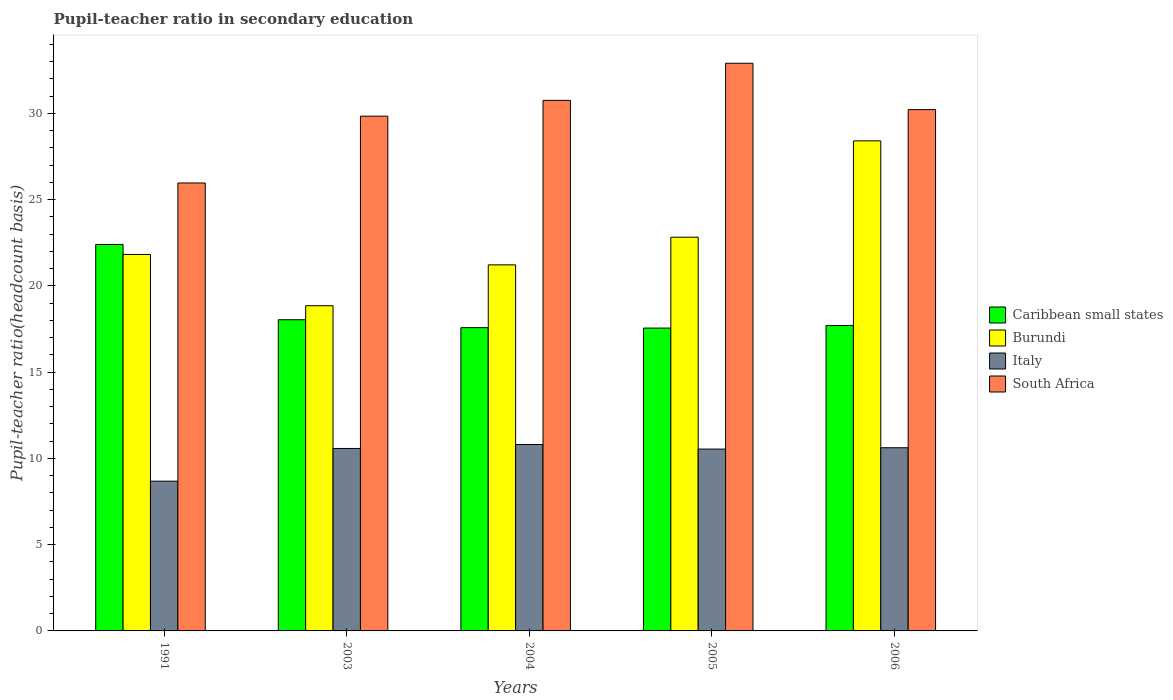How many different coloured bars are there?
Provide a short and direct response. 4. Are the number of bars per tick equal to the number of legend labels?
Ensure brevity in your answer.  Yes. Are the number of bars on each tick of the X-axis equal?
Provide a short and direct response. Yes. How many bars are there on the 5th tick from the left?
Your answer should be compact. 4. What is the label of the 1st group of bars from the left?
Your answer should be very brief. 1991. What is the pupil-teacher ratio in secondary education in Burundi in 2004?
Offer a very short reply. 21.22. Across all years, what is the maximum pupil-teacher ratio in secondary education in South Africa?
Provide a short and direct response. 32.9. Across all years, what is the minimum pupil-teacher ratio in secondary education in Caribbean small states?
Make the answer very short. 17.55. What is the total pupil-teacher ratio in secondary education in Caribbean small states in the graph?
Make the answer very short. 93.27. What is the difference between the pupil-teacher ratio in secondary education in Caribbean small states in 1991 and that in 2004?
Offer a very short reply. 4.82. What is the difference between the pupil-teacher ratio in secondary education in South Africa in 2005 and the pupil-teacher ratio in secondary education in Burundi in 2003?
Provide a short and direct response. 14.05. What is the average pupil-teacher ratio in secondary education in South Africa per year?
Make the answer very short. 29.93. In the year 1991, what is the difference between the pupil-teacher ratio in secondary education in Caribbean small states and pupil-teacher ratio in secondary education in South Africa?
Give a very brief answer. -3.56. In how many years, is the pupil-teacher ratio in secondary education in Italy greater than 13?
Provide a short and direct response. 0. What is the ratio of the pupil-teacher ratio in secondary education in Caribbean small states in 1991 to that in 2004?
Provide a succinct answer. 1.27. What is the difference between the highest and the second highest pupil-teacher ratio in secondary education in Burundi?
Your response must be concise. 5.58. What is the difference between the highest and the lowest pupil-teacher ratio in secondary education in Caribbean small states?
Your answer should be very brief. 4.85. What does the 2nd bar from the left in 2004 represents?
Ensure brevity in your answer.  Burundi. What does the 1st bar from the right in 2003 represents?
Make the answer very short. South Africa. Is it the case that in every year, the sum of the pupil-teacher ratio in secondary education in Caribbean small states and pupil-teacher ratio in secondary education in South Africa is greater than the pupil-teacher ratio in secondary education in Burundi?
Provide a succinct answer. Yes. How many bars are there?
Ensure brevity in your answer.  20. Are all the bars in the graph horizontal?
Provide a short and direct response. No. How many years are there in the graph?
Offer a terse response. 5. Does the graph contain any zero values?
Ensure brevity in your answer.  No. Does the graph contain grids?
Provide a short and direct response. No. How many legend labels are there?
Provide a short and direct response. 4. What is the title of the graph?
Keep it short and to the point. Pupil-teacher ratio in secondary education. Does "Australia" appear as one of the legend labels in the graph?
Your answer should be compact. No. What is the label or title of the Y-axis?
Make the answer very short. Pupil-teacher ratio(headcount basis). What is the Pupil-teacher ratio(headcount basis) in Caribbean small states in 1991?
Provide a short and direct response. 22.4. What is the Pupil-teacher ratio(headcount basis) in Burundi in 1991?
Provide a short and direct response. 21.82. What is the Pupil-teacher ratio(headcount basis) of Italy in 1991?
Provide a short and direct response. 8.68. What is the Pupil-teacher ratio(headcount basis) in South Africa in 1991?
Provide a succinct answer. 25.96. What is the Pupil-teacher ratio(headcount basis) of Caribbean small states in 2003?
Your answer should be very brief. 18.04. What is the Pupil-teacher ratio(headcount basis) in Burundi in 2003?
Ensure brevity in your answer.  18.85. What is the Pupil-teacher ratio(headcount basis) in Italy in 2003?
Ensure brevity in your answer.  10.58. What is the Pupil-teacher ratio(headcount basis) in South Africa in 2003?
Keep it short and to the point. 29.84. What is the Pupil-teacher ratio(headcount basis) of Caribbean small states in 2004?
Your response must be concise. 17.58. What is the Pupil-teacher ratio(headcount basis) of Burundi in 2004?
Provide a succinct answer. 21.22. What is the Pupil-teacher ratio(headcount basis) of Italy in 2004?
Offer a terse response. 10.8. What is the Pupil-teacher ratio(headcount basis) of South Africa in 2004?
Give a very brief answer. 30.75. What is the Pupil-teacher ratio(headcount basis) of Caribbean small states in 2005?
Your answer should be very brief. 17.55. What is the Pupil-teacher ratio(headcount basis) in Burundi in 2005?
Make the answer very short. 22.82. What is the Pupil-teacher ratio(headcount basis) in Italy in 2005?
Your response must be concise. 10.54. What is the Pupil-teacher ratio(headcount basis) of South Africa in 2005?
Provide a short and direct response. 32.9. What is the Pupil-teacher ratio(headcount basis) in Caribbean small states in 2006?
Give a very brief answer. 17.7. What is the Pupil-teacher ratio(headcount basis) in Burundi in 2006?
Your answer should be very brief. 28.4. What is the Pupil-teacher ratio(headcount basis) in Italy in 2006?
Provide a succinct answer. 10.62. What is the Pupil-teacher ratio(headcount basis) of South Africa in 2006?
Your answer should be compact. 30.21. Across all years, what is the maximum Pupil-teacher ratio(headcount basis) of Caribbean small states?
Offer a very short reply. 22.4. Across all years, what is the maximum Pupil-teacher ratio(headcount basis) in Burundi?
Give a very brief answer. 28.4. Across all years, what is the maximum Pupil-teacher ratio(headcount basis) in Italy?
Your answer should be very brief. 10.8. Across all years, what is the maximum Pupil-teacher ratio(headcount basis) of South Africa?
Offer a terse response. 32.9. Across all years, what is the minimum Pupil-teacher ratio(headcount basis) in Caribbean small states?
Offer a very short reply. 17.55. Across all years, what is the minimum Pupil-teacher ratio(headcount basis) in Burundi?
Keep it short and to the point. 18.85. Across all years, what is the minimum Pupil-teacher ratio(headcount basis) of Italy?
Ensure brevity in your answer.  8.68. Across all years, what is the minimum Pupil-teacher ratio(headcount basis) in South Africa?
Your response must be concise. 25.96. What is the total Pupil-teacher ratio(headcount basis) of Caribbean small states in the graph?
Make the answer very short. 93.27. What is the total Pupil-teacher ratio(headcount basis) of Burundi in the graph?
Offer a terse response. 113.11. What is the total Pupil-teacher ratio(headcount basis) of Italy in the graph?
Your response must be concise. 51.22. What is the total Pupil-teacher ratio(headcount basis) in South Africa in the graph?
Give a very brief answer. 149.67. What is the difference between the Pupil-teacher ratio(headcount basis) in Caribbean small states in 1991 and that in 2003?
Provide a short and direct response. 4.36. What is the difference between the Pupil-teacher ratio(headcount basis) of Burundi in 1991 and that in 2003?
Provide a succinct answer. 2.97. What is the difference between the Pupil-teacher ratio(headcount basis) of Italy in 1991 and that in 2003?
Provide a short and direct response. -1.9. What is the difference between the Pupil-teacher ratio(headcount basis) in South Africa in 1991 and that in 2003?
Ensure brevity in your answer.  -3.87. What is the difference between the Pupil-teacher ratio(headcount basis) in Caribbean small states in 1991 and that in 2004?
Give a very brief answer. 4.82. What is the difference between the Pupil-teacher ratio(headcount basis) of Burundi in 1991 and that in 2004?
Make the answer very short. 0.6. What is the difference between the Pupil-teacher ratio(headcount basis) of Italy in 1991 and that in 2004?
Provide a succinct answer. -2.12. What is the difference between the Pupil-teacher ratio(headcount basis) of South Africa in 1991 and that in 2004?
Keep it short and to the point. -4.79. What is the difference between the Pupil-teacher ratio(headcount basis) of Caribbean small states in 1991 and that in 2005?
Your response must be concise. 4.85. What is the difference between the Pupil-teacher ratio(headcount basis) of Burundi in 1991 and that in 2005?
Provide a succinct answer. -1. What is the difference between the Pupil-teacher ratio(headcount basis) in Italy in 1991 and that in 2005?
Provide a succinct answer. -1.86. What is the difference between the Pupil-teacher ratio(headcount basis) of South Africa in 1991 and that in 2005?
Your response must be concise. -6.94. What is the difference between the Pupil-teacher ratio(headcount basis) in Caribbean small states in 1991 and that in 2006?
Keep it short and to the point. 4.7. What is the difference between the Pupil-teacher ratio(headcount basis) in Burundi in 1991 and that in 2006?
Ensure brevity in your answer.  -6.58. What is the difference between the Pupil-teacher ratio(headcount basis) of Italy in 1991 and that in 2006?
Your answer should be compact. -1.94. What is the difference between the Pupil-teacher ratio(headcount basis) of South Africa in 1991 and that in 2006?
Keep it short and to the point. -4.25. What is the difference between the Pupil-teacher ratio(headcount basis) in Caribbean small states in 2003 and that in 2004?
Make the answer very short. 0.46. What is the difference between the Pupil-teacher ratio(headcount basis) of Burundi in 2003 and that in 2004?
Offer a terse response. -2.37. What is the difference between the Pupil-teacher ratio(headcount basis) in Italy in 2003 and that in 2004?
Offer a terse response. -0.23. What is the difference between the Pupil-teacher ratio(headcount basis) in South Africa in 2003 and that in 2004?
Give a very brief answer. -0.92. What is the difference between the Pupil-teacher ratio(headcount basis) of Caribbean small states in 2003 and that in 2005?
Your response must be concise. 0.48. What is the difference between the Pupil-teacher ratio(headcount basis) of Burundi in 2003 and that in 2005?
Offer a very short reply. -3.97. What is the difference between the Pupil-teacher ratio(headcount basis) of Italy in 2003 and that in 2005?
Offer a terse response. 0.04. What is the difference between the Pupil-teacher ratio(headcount basis) of South Africa in 2003 and that in 2005?
Your response must be concise. -3.07. What is the difference between the Pupil-teacher ratio(headcount basis) in Caribbean small states in 2003 and that in 2006?
Provide a short and direct response. 0.34. What is the difference between the Pupil-teacher ratio(headcount basis) in Burundi in 2003 and that in 2006?
Provide a short and direct response. -9.56. What is the difference between the Pupil-teacher ratio(headcount basis) of Italy in 2003 and that in 2006?
Your response must be concise. -0.04. What is the difference between the Pupil-teacher ratio(headcount basis) in South Africa in 2003 and that in 2006?
Provide a succinct answer. -0.38. What is the difference between the Pupil-teacher ratio(headcount basis) of Caribbean small states in 2004 and that in 2005?
Give a very brief answer. 0.02. What is the difference between the Pupil-teacher ratio(headcount basis) of Burundi in 2004 and that in 2005?
Give a very brief answer. -1.6. What is the difference between the Pupil-teacher ratio(headcount basis) in Italy in 2004 and that in 2005?
Give a very brief answer. 0.26. What is the difference between the Pupil-teacher ratio(headcount basis) in South Africa in 2004 and that in 2005?
Keep it short and to the point. -2.15. What is the difference between the Pupil-teacher ratio(headcount basis) in Caribbean small states in 2004 and that in 2006?
Your answer should be compact. -0.12. What is the difference between the Pupil-teacher ratio(headcount basis) in Burundi in 2004 and that in 2006?
Give a very brief answer. -7.19. What is the difference between the Pupil-teacher ratio(headcount basis) in Italy in 2004 and that in 2006?
Give a very brief answer. 0.19. What is the difference between the Pupil-teacher ratio(headcount basis) in South Africa in 2004 and that in 2006?
Your response must be concise. 0.54. What is the difference between the Pupil-teacher ratio(headcount basis) in Caribbean small states in 2005 and that in 2006?
Make the answer very short. -0.15. What is the difference between the Pupil-teacher ratio(headcount basis) of Burundi in 2005 and that in 2006?
Your answer should be very brief. -5.58. What is the difference between the Pupil-teacher ratio(headcount basis) of Italy in 2005 and that in 2006?
Offer a terse response. -0.08. What is the difference between the Pupil-teacher ratio(headcount basis) of South Africa in 2005 and that in 2006?
Your response must be concise. 2.69. What is the difference between the Pupil-teacher ratio(headcount basis) in Caribbean small states in 1991 and the Pupil-teacher ratio(headcount basis) in Burundi in 2003?
Your answer should be compact. 3.55. What is the difference between the Pupil-teacher ratio(headcount basis) in Caribbean small states in 1991 and the Pupil-teacher ratio(headcount basis) in Italy in 2003?
Offer a very short reply. 11.82. What is the difference between the Pupil-teacher ratio(headcount basis) of Caribbean small states in 1991 and the Pupil-teacher ratio(headcount basis) of South Africa in 2003?
Give a very brief answer. -7.44. What is the difference between the Pupil-teacher ratio(headcount basis) of Burundi in 1991 and the Pupil-teacher ratio(headcount basis) of Italy in 2003?
Provide a short and direct response. 11.24. What is the difference between the Pupil-teacher ratio(headcount basis) in Burundi in 1991 and the Pupil-teacher ratio(headcount basis) in South Africa in 2003?
Ensure brevity in your answer.  -8.02. What is the difference between the Pupil-teacher ratio(headcount basis) in Italy in 1991 and the Pupil-teacher ratio(headcount basis) in South Africa in 2003?
Give a very brief answer. -21.16. What is the difference between the Pupil-teacher ratio(headcount basis) of Caribbean small states in 1991 and the Pupil-teacher ratio(headcount basis) of Burundi in 2004?
Give a very brief answer. 1.18. What is the difference between the Pupil-teacher ratio(headcount basis) in Caribbean small states in 1991 and the Pupil-teacher ratio(headcount basis) in Italy in 2004?
Keep it short and to the point. 11.59. What is the difference between the Pupil-teacher ratio(headcount basis) of Caribbean small states in 1991 and the Pupil-teacher ratio(headcount basis) of South Africa in 2004?
Offer a terse response. -8.35. What is the difference between the Pupil-teacher ratio(headcount basis) of Burundi in 1991 and the Pupil-teacher ratio(headcount basis) of Italy in 2004?
Provide a short and direct response. 11.02. What is the difference between the Pupil-teacher ratio(headcount basis) in Burundi in 1991 and the Pupil-teacher ratio(headcount basis) in South Africa in 2004?
Give a very brief answer. -8.93. What is the difference between the Pupil-teacher ratio(headcount basis) of Italy in 1991 and the Pupil-teacher ratio(headcount basis) of South Africa in 2004?
Provide a succinct answer. -22.07. What is the difference between the Pupil-teacher ratio(headcount basis) of Caribbean small states in 1991 and the Pupil-teacher ratio(headcount basis) of Burundi in 2005?
Your answer should be compact. -0.42. What is the difference between the Pupil-teacher ratio(headcount basis) of Caribbean small states in 1991 and the Pupil-teacher ratio(headcount basis) of Italy in 2005?
Provide a succinct answer. 11.86. What is the difference between the Pupil-teacher ratio(headcount basis) in Caribbean small states in 1991 and the Pupil-teacher ratio(headcount basis) in South Africa in 2005?
Offer a very short reply. -10.5. What is the difference between the Pupil-teacher ratio(headcount basis) of Burundi in 1991 and the Pupil-teacher ratio(headcount basis) of Italy in 2005?
Your answer should be very brief. 11.28. What is the difference between the Pupil-teacher ratio(headcount basis) in Burundi in 1991 and the Pupil-teacher ratio(headcount basis) in South Africa in 2005?
Offer a very short reply. -11.08. What is the difference between the Pupil-teacher ratio(headcount basis) of Italy in 1991 and the Pupil-teacher ratio(headcount basis) of South Africa in 2005?
Keep it short and to the point. -24.22. What is the difference between the Pupil-teacher ratio(headcount basis) of Caribbean small states in 1991 and the Pupil-teacher ratio(headcount basis) of Burundi in 2006?
Your answer should be very brief. -6.01. What is the difference between the Pupil-teacher ratio(headcount basis) of Caribbean small states in 1991 and the Pupil-teacher ratio(headcount basis) of Italy in 2006?
Your answer should be compact. 11.78. What is the difference between the Pupil-teacher ratio(headcount basis) of Caribbean small states in 1991 and the Pupil-teacher ratio(headcount basis) of South Africa in 2006?
Your answer should be very brief. -7.82. What is the difference between the Pupil-teacher ratio(headcount basis) of Burundi in 1991 and the Pupil-teacher ratio(headcount basis) of Italy in 2006?
Offer a very short reply. 11.2. What is the difference between the Pupil-teacher ratio(headcount basis) of Burundi in 1991 and the Pupil-teacher ratio(headcount basis) of South Africa in 2006?
Offer a very short reply. -8.39. What is the difference between the Pupil-teacher ratio(headcount basis) in Italy in 1991 and the Pupil-teacher ratio(headcount basis) in South Africa in 2006?
Your response must be concise. -21.54. What is the difference between the Pupil-teacher ratio(headcount basis) in Caribbean small states in 2003 and the Pupil-teacher ratio(headcount basis) in Burundi in 2004?
Offer a very short reply. -3.18. What is the difference between the Pupil-teacher ratio(headcount basis) of Caribbean small states in 2003 and the Pupil-teacher ratio(headcount basis) of Italy in 2004?
Your response must be concise. 7.23. What is the difference between the Pupil-teacher ratio(headcount basis) in Caribbean small states in 2003 and the Pupil-teacher ratio(headcount basis) in South Africa in 2004?
Your response must be concise. -12.71. What is the difference between the Pupil-teacher ratio(headcount basis) of Burundi in 2003 and the Pupil-teacher ratio(headcount basis) of Italy in 2004?
Offer a very short reply. 8.04. What is the difference between the Pupil-teacher ratio(headcount basis) of Burundi in 2003 and the Pupil-teacher ratio(headcount basis) of South Africa in 2004?
Give a very brief answer. -11.9. What is the difference between the Pupil-teacher ratio(headcount basis) of Italy in 2003 and the Pupil-teacher ratio(headcount basis) of South Africa in 2004?
Your answer should be very brief. -20.18. What is the difference between the Pupil-teacher ratio(headcount basis) in Caribbean small states in 2003 and the Pupil-teacher ratio(headcount basis) in Burundi in 2005?
Your response must be concise. -4.78. What is the difference between the Pupil-teacher ratio(headcount basis) in Caribbean small states in 2003 and the Pupil-teacher ratio(headcount basis) in Italy in 2005?
Offer a terse response. 7.5. What is the difference between the Pupil-teacher ratio(headcount basis) in Caribbean small states in 2003 and the Pupil-teacher ratio(headcount basis) in South Africa in 2005?
Keep it short and to the point. -14.87. What is the difference between the Pupil-teacher ratio(headcount basis) in Burundi in 2003 and the Pupil-teacher ratio(headcount basis) in Italy in 2005?
Provide a succinct answer. 8.31. What is the difference between the Pupil-teacher ratio(headcount basis) of Burundi in 2003 and the Pupil-teacher ratio(headcount basis) of South Africa in 2005?
Offer a very short reply. -14.05. What is the difference between the Pupil-teacher ratio(headcount basis) of Italy in 2003 and the Pupil-teacher ratio(headcount basis) of South Africa in 2005?
Your answer should be very brief. -22.33. What is the difference between the Pupil-teacher ratio(headcount basis) in Caribbean small states in 2003 and the Pupil-teacher ratio(headcount basis) in Burundi in 2006?
Keep it short and to the point. -10.37. What is the difference between the Pupil-teacher ratio(headcount basis) of Caribbean small states in 2003 and the Pupil-teacher ratio(headcount basis) of Italy in 2006?
Your answer should be compact. 7.42. What is the difference between the Pupil-teacher ratio(headcount basis) of Caribbean small states in 2003 and the Pupil-teacher ratio(headcount basis) of South Africa in 2006?
Offer a terse response. -12.18. What is the difference between the Pupil-teacher ratio(headcount basis) in Burundi in 2003 and the Pupil-teacher ratio(headcount basis) in Italy in 2006?
Provide a succinct answer. 8.23. What is the difference between the Pupil-teacher ratio(headcount basis) of Burundi in 2003 and the Pupil-teacher ratio(headcount basis) of South Africa in 2006?
Provide a short and direct response. -11.37. What is the difference between the Pupil-teacher ratio(headcount basis) in Italy in 2003 and the Pupil-teacher ratio(headcount basis) in South Africa in 2006?
Give a very brief answer. -19.64. What is the difference between the Pupil-teacher ratio(headcount basis) of Caribbean small states in 2004 and the Pupil-teacher ratio(headcount basis) of Burundi in 2005?
Provide a short and direct response. -5.24. What is the difference between the Pupil-teacher ratio(headcount basis) in Caribbean small states in 2004 and the Pupil-teacher ratio(headcount basis) in Italy in 2005?
Your answer should be compact. 7.04. What is the difference between the Pupil-teacher ratio(headcount basis) of Caribbean small states in 2004 and the Pupil-teacher ratio(headcount basis) of South Africa in 2005?
Your answer should be very brief. -15.32. What is the difference between the Pupil-teacher ratio(headcount basis) in Burundi in 2004 and the Pupil-teacher ratio(headcount basis) in Italy in 2005?
Provide a succinct answer. 10.68. What is the difference between the Pupil-teacher ratio(headcount basis) in Burundi in 2004 and the Pupil-teacher ratio(headcount basis) in South Africa in 2005?
Keep it short and to the point. -11.69. What is the difference between the Pupil-teacher ratio(headcount basis) of Italy in 2004 and the Pupil-teacher ratio(headcount basis) of South Africa in 2005?
Your response must be concise. -22.1. What is the difference between the Pupil-teacher ratio(headcount basis) in Caribbean small states in 2004 and the Pupil-teacher ratio(headcount basis) in Burundi in 2006?
Your answer should be very brief. -10.83. What is the difference between the Pupil-teacher ratio(headcount basis) of Caribbean small states in 2004 and the Pupil-teacher ratio(headcount basis) of Italy in 2006?
Keep it short and to the point. 6.96. What is the difference between the Pupil-teacher ratio(headcount basis) of Caribbean small states in 2004 and the Pupil-teacher ratio(headcount basis) of South Africa in 2006?
Give a very brief answer. -12.64. What is the difference between the Pupil-teacher ratio(headcount basis) in Burundi in 2004 and the Pupil-teacher ratio(headcount basis) in Italy in 2006?
Ensure brevity in your answer.  10.6. What is the difference between the Pupil-teacher ratio(headcount basis) of Burundi in 2004 and the Pupil-teacher ratio(headcount basis) of South Africa in 2006?
Make the answer very short. -9. What is the difference between the Pupil-teacher ratio(headcount basis) in Italy in 2004 and the Pupil-teacher ratio(headcount basis) in South Africa in 2006?
Your response must be concise. -19.41. What is the difference between the Pupil-teacher ratio(headcount basis) in Caribbean small states in 2005 and the Pupil-teacher ratio(headcount basis) in Burundi in 2006?
Give a very brief answer. -10.85. What is the difference between the Pupil-teacher ratio(headcount basis) in Caribbean small states in 2005 and the Pupil-teacher ratio(headcount basis) in Italy in 2006?
Provide a short and direct response. 6.94. What is the difference between the Pupil-teacher ratio(headcount basis) of Caribbean small states in 2005 and the Pupil-teacher ratio(headcount basis) of South Africa in 2006?
Offer a very short reply. -12.66. What is the difference between the Pupil-teacher ratio(headcount basis) of Burundi in 2005 and the Pupil-teacher ratio(headcount basis) of Italy in 2006?
Make the answer very short. 12.2. What is the difference between the Pupil-teacher ratio(headcount basis) of Burundi in 2005 and the Pupil-teacher ratio(headcount basis) of South Africa in 2006?
Ensure brevity in your answer.  -7.39. What is the difference between the Pupil-teacher ratio(headcount basis) of Italy in 2005 and the Pupil-teacher ratio(headcount basis) of South Africa in 2006?
Your answer should be very brief. -19.67. What is the average Pupil-teacher ratio(headcount basis) in Caribbean small states per year?
Your answer should be very brief. 18.65. What is the average Pupil-teacher ratio(headcount basis) in Burundi per year?
Make the answer very short. 22.62. What is the average Pupil-teacher ratio(headcount basis) in Italy per year?
Give a very brief answer. 10.24. What is the average Pupil-teacher ratio(headcount basis) of South Africa per year?
Keep it short and to the point. 29.93. In the year 1991, what is the difference between the Pupil-teacher ratio(headcount basis) in Caribbean small states and Pupil-teacher ratio(headcount basis) in Burundi?
Give a very brief answer. 0.58. In the year 1991, what is the difference between the Pupil-teacher ratio(headcount basis) of Caribbean small states and Pupil-teacher ratio(headcount basis) of Italy?
Provide a succinct answer. 13.72. In the year 1991, what is the difference between the Pupil-teacher ratio(headcount basis) in Caribbean small states and Pupil-teacher ratio(headcount basis) in South Africa?
Give a very brief answer. -3.56. In the year 1991, what is the difference between the Pupil-teacher ratio(headcount basis) in Burundi and Pupil-teacher ratio(headcount basis) in Italy?
Give a very brief answer. 13.14. In the year 1991, what is the difference between the Pupil-teacher ratio(headcount basis) in Burundi and Pupil-teacher ratio(headcount basis) in South Africa?
Give a very brief answer. -4.14. In the year 1991, what is the difference between the Pupil-teacher ratio(headcount basis) of Italy and Pupil-teacher ratio(headcount basis) of South Africa?
Give a very brief answer. -17.28. In the year 2003, what is the difference between the Pupil-teacher ratio(headcount basis) in Caribbean small states and Pupil-teacher ratio(headcount basis) in Burundi?
Your answer should be compact. -0.81. In the year 2003, what is the difference between the Pupil-teacher ratio(headcount basis) in Caribbean small states and Pupil-teacher ratio(headcount basis) in Italy?
Provide a succinct answer. 7.46. In the year 2003, what is the difference between the Pupil-teacher ratio(headcount basis) of Caribbean small states and Pupil-teacher ratio(headcount basis) of South Africa?
Keep it short and to the point. -11.8. In the year 2003, what is the difference between the Pupil-teacher ratio(headcount basis) of Burundi and Pupil-teacher ratio(headcount basis) of Italy?
Provide a short and direct response. 8.27. In the year 2003, what is the difference between the Pupil-teacher ratio(headcount basis) in Burundi and Pupil-teacher ratio(headcount basis) in South Africa?
Make the answer very short. -10.99. In the year 2003, what is the difference between the Pupil-teacher ratio(headcount basis) in Italy and Pupil-teacher ratio(headcount basis) in South Africa?
Your answer should be very brief. -19.26. In the year 2004, what is the difference between the Pupil-teacher ratio(headcount basis) of Caribbean small states and Pupil-teacher ratio(headcount basis) of Burundi?
Provide a short and direct response. -3.64. In the year 2004, what is the difference between the Pupil-teacher ratio(headcount basis) of Caribbean small states and Pupil-teacher ratio(headcount basis) of Italy?
Offer a terse response. 6.77. In the year 2004, what is the difference between the Pupil-teacher ratio(headcount basis) in Caribbean small states and Pupil-teacher ratio(headcount basis) in South Africa?
Give a very brief answer. -13.17. In the year 2004, what is the difference between the Pupil-teacher ratio(headcount basis) in Burundi and Pupil-teacher ratio(headcount basis) in Italy?
Offer a terse response. 10.41. In the year 2004, what is the difference between the Pupil-teacher ratio(headcount basis) of Burundi and Pupil-teacher ratio(headcount basis) of South Africa?
Keep it short and to the point. -9.53. In the year 2004, what is the difference between the Pupil-teacher ratio(headcount basis) of Italy and Pupil-teacher ratio(headcount basis) of South Africa?
Ensure brevity in your answer.  -19.95. In the year 2005, what is the difference between the Pupil-teacher ratio(headcount basis) in Caribbean small states and Pupil-teacher ratio(headcount basis) in Burundi?
Make the answer very short. -5.27. In the year 2005, what is the difference between the Pupil-teacher ratio(headcount basis) of Caribbean small states and Pupil-teacher ratio(headcount basis) of Italy?
Your response must be concise. 7.01. In the year 2005, what is the difference between the Pupil-teacher ratio(headcount basis) in Caribbean small states and Pupil-teacher ratio(headcount basis) in South Africa?
Your answer should be very brief. -15.35. In the year 2005, what is the difference between the Pupil-teacher ratio(headcount basis) of Burundi and Pupil-teacher ratio(headcount basis) of Italy?
Make the answer very short. 12.28. In the year 2005, what is the difference between the Pupil-teacher ratio(headcount basis) of Burundi and Pupil-teacher ratio(headcount basis) of South Africa?
Offer a very short reply. -10.08. In the year 2005, what is the difference between the Pupil-teacher ratio(headcount basis) of Italy and Pupil-teacher ratio(headcount basis) of South Africa?
Provide a short and direct response. -22.36. In the year 2006, what is the difference between the Pupil-teacher ratio(headcount basis) in Caribbean small states and Pupil-teacher ratio(headcount basis) in Burundi?
Your answer should be compact. -10.7. In the year 2006, what is the difference between the Pupil-teacher ratio(headcount basis) in Caribbean small states and Pupil-teacher ratio(headcount basis) in Italy?
Give a very brief answer. 7.08. In the year 2006, what is the difference between the Pupil-teacher ratio(headcount basis) of Caribbean small states and Pupil-teacher ratio(headcount basis) of South Africa?
Give a very brief answer. -12.51. In the year 2006, what is the difference between the Pupil-teacher ratio(headcount basis) in Burundi and Pupil-teacher ratio(headcount basis) in Italy?
Provide a short and direct response. 17.79. In the year 2006, what is the difference between the Pupil-teacher ratio(headcount basis) of Burundi and Pupil-teacher ratio(headcount basis) of South Africa?
Give a very brief answer. -1.81. In the year 2006, what is the difference between the Pupil-teacher ratio(headcount basis) in Italy and Pupil-teacher ratio(headcount basis) in South Africa?
Keep it short and to the point. -19.6. What is the ratio of the Pupil-teacher ratio(headcount basis) in Caribbean small states in 1991 to that in 2003?
Offer a very short reply. 1.24. What is the ratio of the Pupil-teacher ratio(headcount basis) of Burundi in 1991 to that in 2003?
Give a very brief answer. 1.16. What is the ratio of the Pupil-teacher ratio(headcount basis) in Italy in 1991 to that in 2003?
Offer a very short reply. 0.82. What is the ratio of the Pupil-teacher ratio(headcount basis) in South Africa in 1991 to that in 2003?
Provide a short and direct response. 0.87. What is the ratio of the Pupil-teacher ratio(headcount basis) in Caribbean small states in 1991 to that in 2004?
Ensure brevity in your answer.  1.27. What is the ratio of the Pupil-teacher ratio(headcount basis) of Burundi in 1991 to that in 2004?
Give a very brief answer. 1.03. What is the ratio of the Pupil-teacher ratio(headcount basis) in Italy in 1991 to that in 2004?
Give a very brief answer. 0.8. What is the ratio of the Pupil-teacher ratio(headcount basis) in South Africa in 1991 to that in 2004?
Your answer should be compact. 0.84. What is the ratio of the Pupil-teacher ratio(headcount basis) of Caribbean small states in 1991 to that in 2005?
Your answer should be compact. 1.28. What is the ratio of the Pupil-teacher ratio(headcount basis) in Burundi in 1991 to that in 2005?
Your response must be concise. 0.96. What is the ratio of the Pupil-teacher ratio(headcount basis) of Italy in 1991 to that in 2005?
Your answer should be compact. 0.82. What is the ratio of the Pupil-teacher ratio(headcount basis) of South Africa in 1991 to that in 2005?
Your answer should be very brief. 0.79. What is the ratio of the Pupil-teacher ratio(headcount basis) of Caribbean small states in 1991 to that in 2006?
Your answer should be very brief. 1.27. What is the ratio of the Pupil-teacher ratio(headcount basis) in Burundi in 1991 to that in 2006?
Offer a very short reply. 0.77. What is the ratio of the Pupil-teacher ratio(headcount basis) in Italy in 1991 to that in 2006?
Provide a short and direct response. 0.82. What is the ratio of the Pupil-teacher ratio(headcount basis) in South Africa in 1991 to that in 2006?
Make the answer very short. 0.86. What is the ratio of the Pupil-teacher ratio(headcount basis) in Caribbean small states in 2003 to that in 2004?
Make the answer very short. 1.03. What is the ratio of the Pupil-teacher ratio(headcount basis) in Burundi in 2003 to that in 2004?
Keep it short and to the point. 0.89. What is the ratio of the Pupil-teacher ratio(headcount basis) of Italy in 2003 to that in 2004?
Offer a very short reply. 0.98. What is the ratio of the Pupil-teacher ratio(headcount basis) in South Africa in 2003 to that in 2004?
Offer a terse response. 0.97. What is the ratio of the Pupil-teacher ratio(headcount basis) of Caribbean small states in 2003 to that in 2005?
Offer a very short reply. 1.03. What is the ratio of the Pupil-teacher ratio(headcount basis) of Burundi in 2003 to that in 2005?
Offer a terse response. 0.83. What is the ratio of the Pupil-teacher ratio(headcount basis) in Italy in 2003 to that in 2005?
Ensure brevity in your answer.  1. What is the ratio of the Pupil-teacher ratio(headcount basis) in South Africa in 2003 to that in 2005?
Offer a terse response. 0.91. What is the ratio of the Pupil-teacher ratio(headcount basis) in Caribbean small states in 2003 to that in 2006?
Keep it short and to the point. 1.02. What is the ratio of the Pupil-teacher ratio(headcount basis) of Burundi in 2003 to that in 2006?
Offer a very short reply. 0.66. What is the ratio of the Pupil-teacher ratio(headcount basis) in South Africa in 2003 to that in 2006?
Offer a very short reply. 0.99. What is the ratio of the Pupil-teacher ratio(headcount basis) of Burundi in 2004 to that in 2005?
Make the answer very short. 0.93. What is the ratio of the Pupil-teacher ratio(headcount basis) of Italy in 2004 to that in 2005?
Your answer should be very brief. 1.03. What is the ratio of the Pupil-teacher ratio(headcount basis) of South Africa in 2004 to that in 2005?
Your answer should be very brief. 0.93. What is the ratio of the Pupil-teacher ratio(headcount basis) of Burundi in 2004 to that in 2006?
Provide a succinct answer. 0.75. What is the ratio of the Pupil-teacher ratio(headcount basis) of Italy in 2004 to that in 2006?
Your answer should be compact. 1.02. What is the ratio of the Pupil-teacher ratio(headcount basis) in South Africa in 2004 to that in 2006?
Give a very brief answer. 1.02. What is the ratio of the Pupil-teacher ratio(headcount basis) in Burundi in 2005 to that in 2006?
Your response must be concise. 0.8. What is the ratio of the Pupil-teacher ratio(headcount basis) in South Africa in 2005 to that in 2006?
Give a very brief answer. 1.09. What is the difference between the highest and the second highest Pupil-teacher ratio(headcount basis) of Caribbean small states?
Offer a very short reply. 4.36. What is the difference between the highest and the second highest Pupil-teacher ratio(headcount basis) in Burundi?
Ensure brevity in your answer.  5.58. What is the difference between the highest and the second highest Pupil-teacher ratio(headcount basis) of Italy?
Ensure brevity in your answer.  0.19. What is the difference between the highest and the second highest Pupil-teacher ratio(headcount basis) of South Africa?
Give a very brief answer. 2.15. What is the difference between the highest and the lowest Pupil-teacher ratio(headcount basis) of Caribbean small states?
Keep it short and to the point. 4.85. What is the difference between the highest and the lowest Pupil-teacher ratio(headcount basis) of Burundi?
Provide a succinct answer. 9.56. What is the difference between the highest and the lowest Pupil-teacher ratio(headcount basis) in Italy?
Offer a very short reply. 2.12. What is the difference between the highest and the lowest Pupil-teacher ratio(headcount basis) in South Africa?
Give a very brief answer. 6.94. 